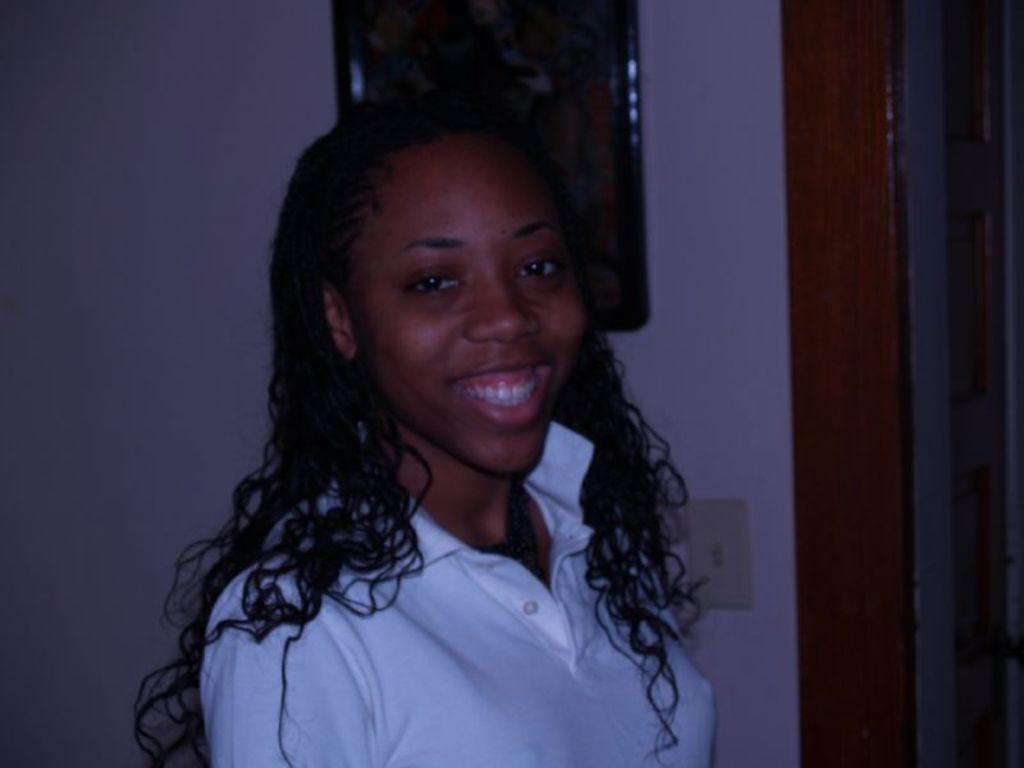Who is present in the image? There is a woman in the image. What is the woman's facial expression? The woman is smiling. What can be seen in the background of the image? There is a plain wall in the background of the image. Are there any objects attached to the wall in the background? Yes, there is a frame attached to the wall in the background of the image. How many babies are crawling on the floor in the image? There are no babies present in the image; it features a woman smiling in front of a plain wall with a frame attached to it. 